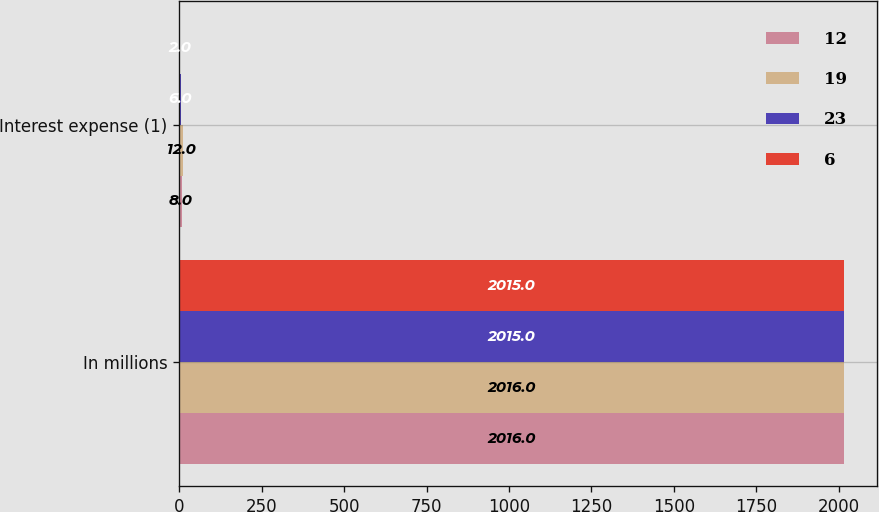<chart> <loc_0><loc_0><loc_500><loc_500><stacked_bar_chart><ecel><fcel>In millions<fcel>Interest expense (1)<nl><fcel>12<fcel>2016<fcel>8<nl><fcel>19<fcel>2016<fcel>12<nl><fcel>23<fcel>2015<fcel>6<nl><fcel>6<fcel>2015<fcel>2<nl></chart> 